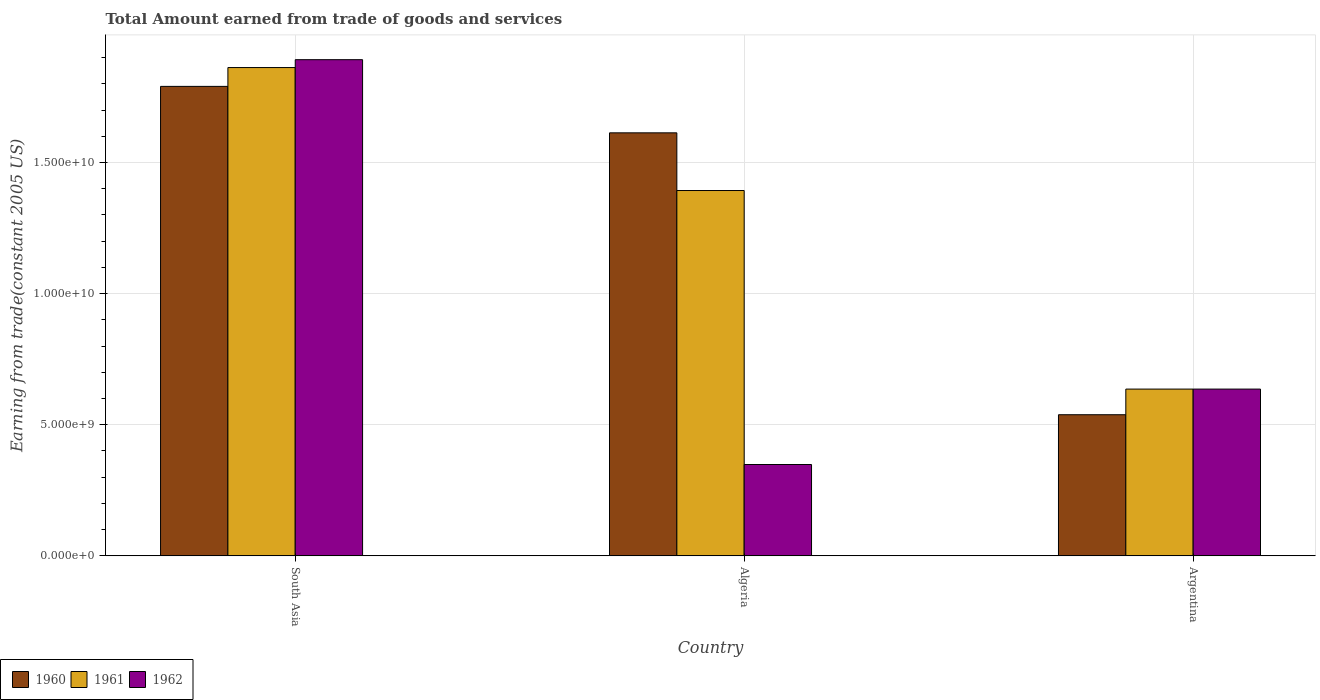How many different coloured bars are there?
Provide a short and direct response. 3. Are the number of bars on each tick of the X-axis equal?
Ensure brevity in your answer.  Yes. What is the label of the 3rd group of bars from the left?
Your answer should be compact. Argentina. In how many cases, is the number of bars for a given country not equal to the number of legend labels?
Your response must be concise. 0. What is the total amount earned by trading goods and services in 1962 in Argentina?
Your answer should be compact. 6.36e+09. Across all countries, what is the maximum total amount earned by trading goods and services in 1962?
Offer a very short reply. 1.89e+1. Across all countries, what is the minimum total amount earned by trading goods and services in 1962?
Provide a short and direct response. 3.48e+09. In which country was the total amount earned by trading goods and services in 1962 maximum?
Offer a terse response. South Asia. What is the total total amount earned by trading goods and services in 1961 in the graph?
Your response must be concise. 3.89e+1. What is the difference between the total amount earned by trading goods and services in 1960 in Argentina and that in South Asia?
Offer a very short reply. -1.25e+1. What is the difference between the total amount earned by trading goods and services in 1961 in Algeria and the total amount earned by trading goods and services in 1962 in South Asia?
Make the answer very short. -4.99e+09. What is the average total amount earned by trading goods and services in 1960 per country?
Provide a succinct answer. 1.31e+1. What is the difference between the total amount earned by trading goods and services of/in 1962 and total amount earned by trading goods and services of/in 1961 in Algeria?
Offer a very short reply. -1.04e+1. In how many countries, is the total amount earned by trading goods and services in 1961 greater than 12000000000 US$?
Your response must be concise. 2. What is the ratio of the total amount earned by trading goods and services in 1962 in Algeria to that in South Asia?
Provide a succinct answer. 0.18. What is the difference between the highest and the second highest total amount earned by trading goods and services in 1962?
Give a very brief answer. 1.54e+1. What is the difference between the highest and the lowest total amount earned by trading goods and services in 1962?
Provide a short and direct response. 1.54e+1. In how many countries, is the total amount earned by trading goods and services in 1961 greater than the average total amount earned by trading goods and services in 1961 taken over all countries?
Offer a terse response. 2. What does the 1st bar from the left in Algeria represents?
Your response must be concise. 1960. What does the 3rd bar from the right in Algeria represents?
Ensure brevity in your answer.  1960. Is it the case that in every country, the sum of the total amount earned by trading goods and services in 1960 and total amount earned by trading goods and services in 1962 is greater than the total amount earned by trading goods and services in 1961?
Ensure brevity in your answer.  Yes. Are all the bars in the graph horizontal?
Offer a terse response. No. What is the difference between two consecutive major ticks on the Y-axis?
Provide a succinct answer. 5.00e+09. Are the values on the major ticks of Y-axis written in scientific E-notation?
Offer a very short reply. Yes. Does the graph contain grids?
Your response must be concise. Yes. Where does the legend appear in the graph?
Your answer should be compact. Bottom left. How many legend labels are there?
Your answer should be very brief. 3. How are the legend labels stacked?
Your response must be concise. Horizontal. What is the title of the graph?
Provide a succinct answer. Total Amount earned from trade of goods and services. Does "1972" appear as one of the legend labels in the graph?
Provide a short and direct response. No. What is the label or title of the Y-axis?
Offer a very short reply. Earning from trade(constant 2005 US). What is the Earning from trade(constant 2005 US) in 1960 in South Asia?
Keep it short and to the point. 1.79e+1. What is the Earning from trade(constant 2005 US) in 1961 in South Asia?
Your answer should be compact. 1.86e+1. What is the Earning from trade(constant 2005 US) of 1962 in South Asia?
Give a very brief answer. 1.89e+1. What is the Earning from trade(constant 2005 US) of 1960 in Algeria?
Make the answer very short. 1.61e+1. What is the Earning from trade(constant 2005 US) of 1961 in Algeria?
Offer a very short reply. 1.39e+1. What is the Earning from trade(constant 2005 US) of 1962 in Algeria?
Offer a very short reply. 3.48e+09. What is the Earning from trade(constant 2005 US) in 1960 in Argentina?
Your answer should be compact. 5.38e+09. What is the Earning from trade(constant 2005 US) in 1961 in Argentina?
Make the answer very short. 6.36e+09. What is the Earning from trade(constant 2005 US) of 1962 in Argentina?
Offer a terse response. 6.36e+09. Across all countries, what is the maximum Earning from trade(constant 2005 US) of 1960?
Offer a terse response. 1.79e+1. Across all countries, what is the maximum Earning from trade(constant 2005 US) of 1961?
Offer a very short reply. 1.86e+1. Across all countries, what is the maximum Earning from trade(constant 2005 US) of 1962?
Offer a terse response. 1.89e+1. Across all countries, what is the minimum Earning from trade(constant 2005 US) in 1960?
Your answer should be very brief. 5.38e+09. Across all countries, what is the minimum Earning from trade(constant 2005 US) in 1961?
Provide a succinct answer. 6.36e+09. Across all countries, what is the minimum Earning from trade(constant 2005 US) in 1962?
Provide a short and direct response. 3.48e+09. What is the total Earning from trade(constant 2005 US) in 1960 in the graph?
Provide a succinct answer. 3.94e+1. What is the total Earning from trade(constant 2005 US) in 1961 in the graph?
Make the answer very short. 3.89e+1. What is the total Earning from trade(constant 2005 US) of 1962 in the graph?
Your response must be concise. 2.88e+1. What is the difference between the Earning from trade(constant 2005 US) of 1960 in South Asia and that in Algeria?
Offer a very short reply. 1.77e+09. What is the difference between the Earning from trade(constant 2005 US) of 1961 in South Asia and that in Algeria?
Your answer should be compact. 4.69e+09. What is the difference between the Earning from trade(constant 2005 US) in 1962 in South Asia and that in Algeria?
Your response must be concise. 1.54e+1. What is the difference between the Earning from trade(constant 2005 US) in 1960 in South Asia and that in Argentina?
Ensure brevity in your answer.  1.25e+1. What is the difference between the Earning from trade(constant 2005 US) in 1961 in South Asia and that in Argentina?
Keep it short and to the point. 1.23e+1. What is the difference between the Earning from trade(constant 2005 US) in 1962 in South Asia and that in Argentina?
Give a very brief answer. 1.26e+1. What is the difference between the Earning from trade(constant 2005 US) of 1960 in Algeria and that in Argentina?
Keep it short and to the point. 1.08e+1. What is the difference between the Earning from trade(constant 2005 US) in 1961 in Algeria and that in Argentina?
Keep it short and to the point. 7.57e+09. What is the difference between the Earning from trade(constant 2005 US) in 1962 in Algeria and that in Argentina?
Provide a succinct answer. -2.88e+09. What is the difference between the Earning from trade(constant 2005 US) of 1960 in South Asia and the Earning from trade(constant 2005 US) of 1961 in Algeria?
Ensure brevity in your answer.  3.97e+09. What is the difference between the Earning from trade(constant 2005 US) of 1960 in South Asia and the Earning from trade(constant 2005 US) of 1962 in Algeria?
Make the answer very short. 1.44e+1. What is the difference between the Earning from trade(constant 2005 US) in 1961 in South Asia and the Earning from trade(constant 2005 US) in 1962 in Algeria?
Ensure brevity in your answer.  1.51e+1. What is the difference between the Earning from trade(constant 2005 US) in 1960 in South Asia and the Earning from trade(constant 2005 US) in 1961 in Argentina?
Your response must be concise. 1.15e+1. What is the difference between the Earning from trade(constant 2005 US) in 1960 in South Asia and the Earning from trade(constant 2005 US) in 1962 in Argentina?
Keep it short and to the point. 1.15e+1. What is the difference between the Earning from trade(constant 2005 US) of 1961 in South Asia and the Earning from trade(constant 2005 US) of 1962 in Argentina?
Provide a succinct answer. 1.23e+1. What is the difference between the Earning from trade(constant 2005 US) in 1960 in Algeria and the Earning from trade(constant 2005 US) in 1961 in Argentina?
Ensure brevity in your answer.  9.77e+09. What is the difference between the Earning from trade(constant 2005 US) of 1960 in Algeria and the Earning from trade(constant 2005 US) of 1962 in Argentina?
Ensure brevity in your answer.  9.77e+09. What is the difference between the Earning from trade(constant 2005 US) in 1961 in Algeria and the Earning from trade(constant 2005 US) in 1962 in Argentina?
Your answer should be compact. 7.57e+09. What is the average Earning from trade(constant 2005 US) in 1960 per country?
Give a very brief answer. 1.31e+1. What is the average Earning from trade(constant 2005 US) in 1961 per country?
Provide a short and direct response. 1.30e+1. What is the average Earning from trade(constant 2005 US) in 1962 per country?
Your answer should be compact. 9.59e+09. What is the difference between the Earning from trade(constant 2005 US) in 1960 and Earning from trade(constant 2005 US) in 1961 in South Asia?
Keep it short and to the point. -7.18e+08. What is the difference between the Earning from trade(constant 2005 US) in 1960 and Earning from trade(constant 2005 US) in 1962 in South Asia?
Offer a very short reply. -1.02e+09. What is the difference between the Earning from trade(constant 2005 US) in 1961 and Earning from trade(constant 2005 US) in 1962 in South Asia?
Provide a succinct answer. -3.00e+08. What is the difference between the Earning from trade(constant 2005 US) in 1960 and Earning from trade(constant 2005 US) in 1961 in Algeria?
Give a very brief answer. 2.20e+09. What is the difference between the Earning from trade(constant 2005 US) in 1960 and Earning from trade(constant 2005 US) in 1962 in Algeria?
Ensure brevity in your answer.  1.26e+1. What is the difference between the Earning from trade(constant 2005 US) in 1961 and Earning from trade(constant 2005 US) in 1962 in Algeria?
Ensure brevity in your answer.  1.04e+1. What is the difference between the Earning from trade(constant 2005 US) of 1960 and Earning from trade(constant 2005 US) of 1961 in Argentina?
Offer a very short reply. -9.78e+08. What is the difference between the Earning from trade(constant 2005 US) of 1960 and Earning from trade(constant 2005 US) of 1962 in Argentina?
Provide a short and direct response. -9.78e+08. What is the ratio of the Earning from trade(constant 2005 US) in 1960 in South Asia to that in Algeria?
Provide a succinct answer. 1.11. What is the ratio of the Earning from trade(constant 2005 US) in 1961 in South Asia to that in Algeria?
Ensure brevity in your answer.  1.34. What is the ratio of the Earning from trade(constant 2005 US) in 1962 in South Asia to that in Algeria?
Your answer should be compact. 5.43. What is the ratio of the Earning from trade(constant 2005 US) of 1960 in South Asia to that in Argentina?
Your response must be concise. 3.33. What is the ratio of the Earning from trade(constant 2005 US) of 1961 in South Asia to that in Argentina?
Give a very brief answer. 2.93. What is the ratio of the Earning from trade(constant 2005 US) of 1962 in South Asia to that in Argentina?
Your response must be concise. 2.98. What is the ratio of the Earning from trade(constant 2005 US) in 1960 in Algeria to that in Argentina?
Provide a succinct answer. 3. What is the ratio of the Earning from trade(constant 2005 US) in 1961 in Algeria to that in Argentina?
Your answer should be compact. 2.19. What is the ratio of the Earning from trade(constant 2005 US) in 1962 in Algeria to that in Argentina?
Give a very brief answer. 0.55. What is the difference between the highest and the second highest Earning from trade(constant 2005 US) of 1960?
Your answer should be compact. 1.77e+09. What is the difference between the highest and the second highest Earning from trade(constant 2005 US) of 1961?
Offer a very short reply. 4.69e+09. What is the difference between the highest and the second highest Earning from trade(constant 2005 US) in 1962?
Ensure brevity in your answer.  1.26e+1. What is the difference between the highest and the lowest Earning from trade(constant 2005 US) of 1960?
Offer a terse response. 1.25e+1. What is the difference between the highest and the lowest Earning from trade(constant 2005 US) in 1961?
Keep it short and to the point. 1.23e+1. What is the difference between the highest and the lowest Earning from trade(constant 2005 US) of 1962?
Ensure brevity in your answer.  1.54e+1. 